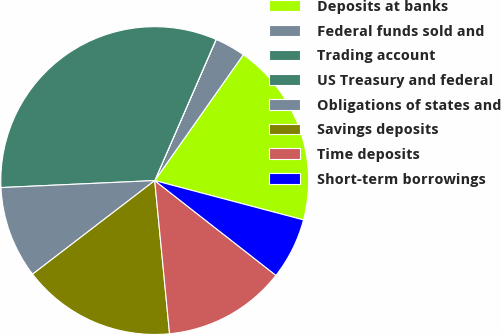Convert chart. <chart><loc_0><loc_0><loc_500><loc_500><pie_chart><fcel>Deposits at banks<fcel>Federal funds sold and<fcel>Trading account<fcel>US Treasury and federal<fcel>Obligations of states and<fcel>Savings deposits<fcel>Time deposits<fcel>Short-term borrowings<nl><fcel>19.35%<fcel>3.23%<fcel>0.01%<fcel>32.25%<fcel>9.68%<fcel>16.13%<fcel>12.9%<fcel>6.45%<nl></chart> 